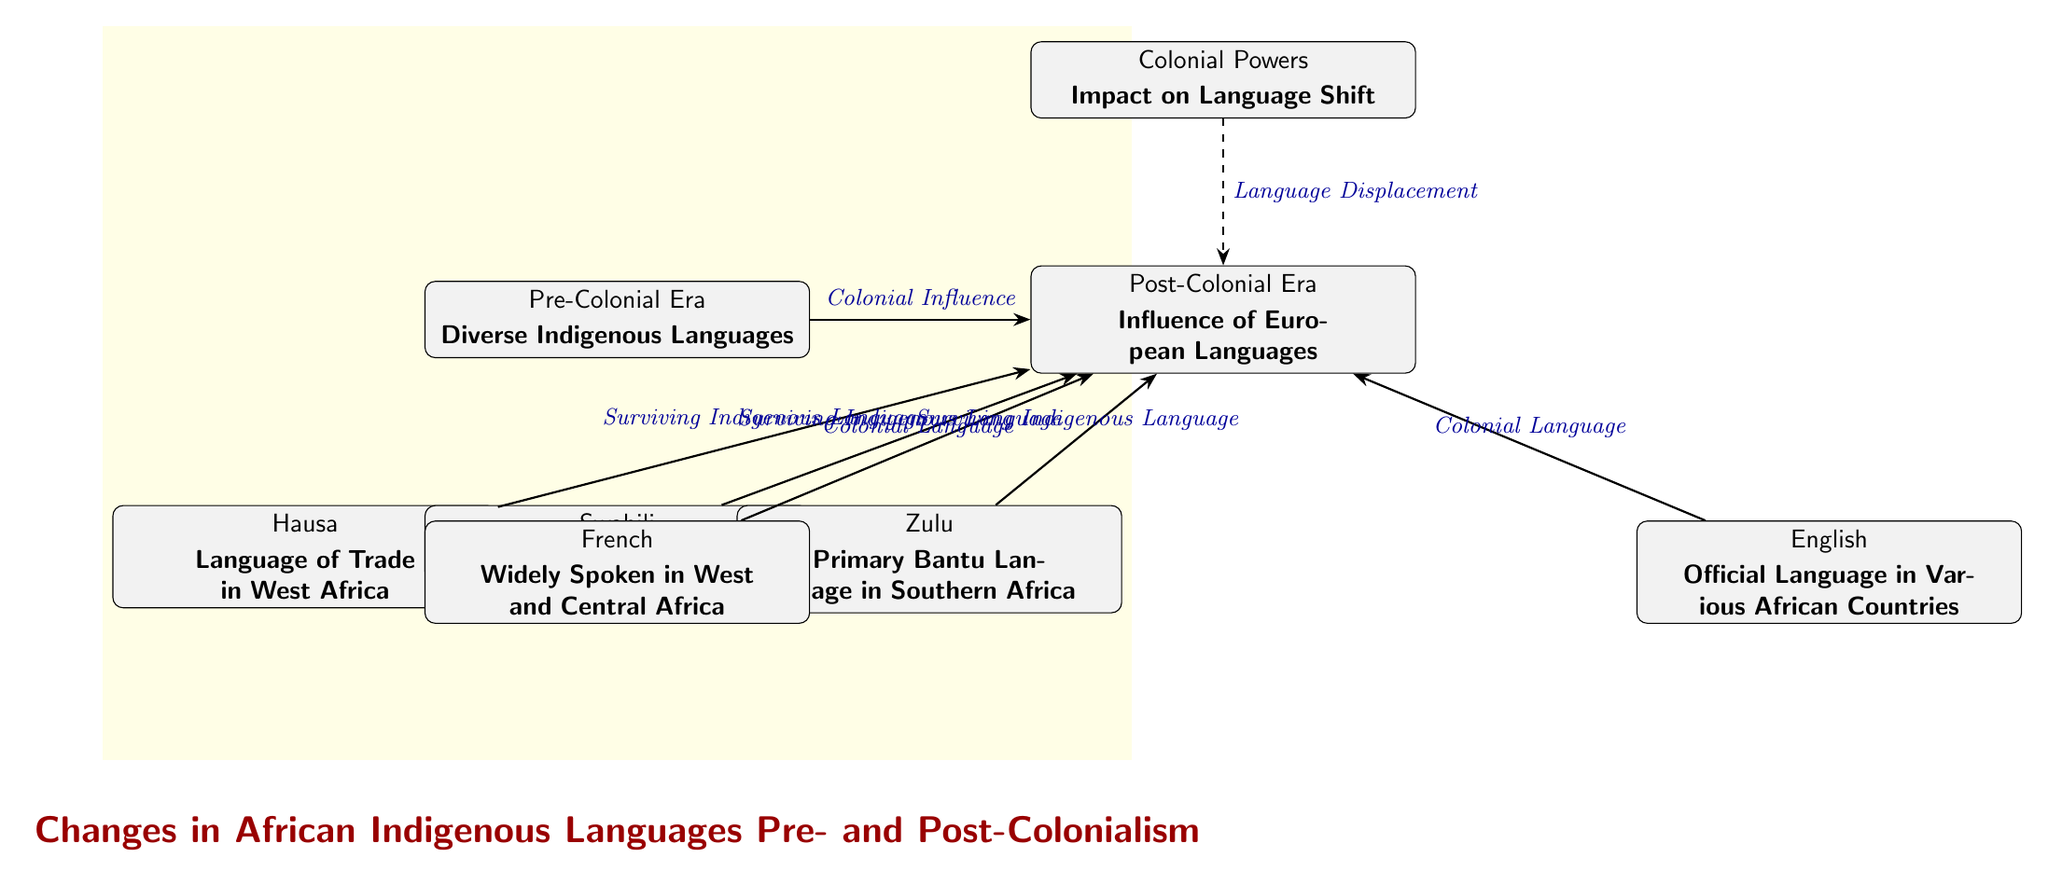What were the dominant themes in the Pre-Colonial Era in African languages? The diagram shows that in the Pre-Colonial Era, the primary theme was "Diverse Indigenous Languages," which highlights the linguistic variety that existed before colonial influence led to significant changes.
Answer: Diverse Indigenous Languages Which three indigenous languages are indicated in the Pre-Colonial Era section? The diagram lists Hausa, Swahili, and Zulu as the three indigenous languages from the Pre-Colonial Era, demonstrating the linguistic diversity present before colonial rule.
Answer: Hausa, Swahili, Zulu What influence does the diagram suggest created a shift in languages post-colonialism? The diagram illustrates that colonial influence is the main factor that led to changes in the linguistic landscape of African societies after colonization, impacting the use of indigenous languages.
Answer: Colonial Influence Which colonial languages are highlighted in the Post-Colonial Era? The diagram identifies French and English as the two primary colonial languages that gained prominence in the Post-Colonial Era, illustrating the impact of colonial powers on local languages.
Answer: French, English How many surviving indigenous languages are depicted transitioning to the Post-Colonial Era? The diagram indicates that three surviving indigenous languages (Hausa, Swahili, and Zulu) are represented in the Post-Colonial Era, showing persistence despite colonial impacts.
Answer: 3 What is the relationship between the Colonial Powers and the Post-Colonial Era languages? The diagram distinctly shows that colonial powers caused a "Language Displacement" effect, leading to the adoption of colonial languages like French and English in the Post-Colonial Era while indigenous languages like Hausa, Swahili, and Zulu were retained.
Answer: Language Displacement What does the dashed arrow represent in the diagram? The dashed arrow indicates a relationship labeled "Language Displacement," which signifies the impact of colonial powers on the decline or transformation of indigenous languages following colonization.
Answer: Language Displacement How does Swahili transition according to the diagram? The diagram illustrates that Swahili, as a lingua franca in East Africa, survives the impact of colonialism, transitioning into the Post-Colonial Era while still being noted as an indigenous language.
Answer: Surviving Indigenous Language 